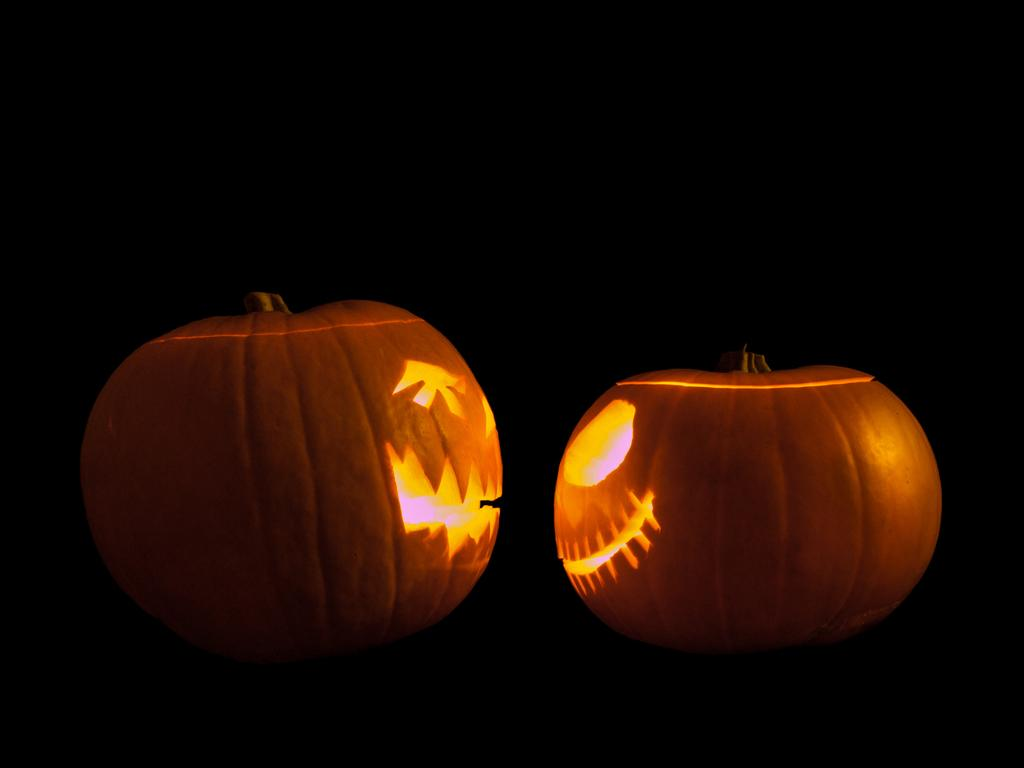What objects are present in the image? There are pumpkins in the image. Can you describe the background of the image? The background of the image is dark. What type of distribution is being made with the oatmeal in the image? There is no oatmeal present in the image, and therefore no distribution is being made. 